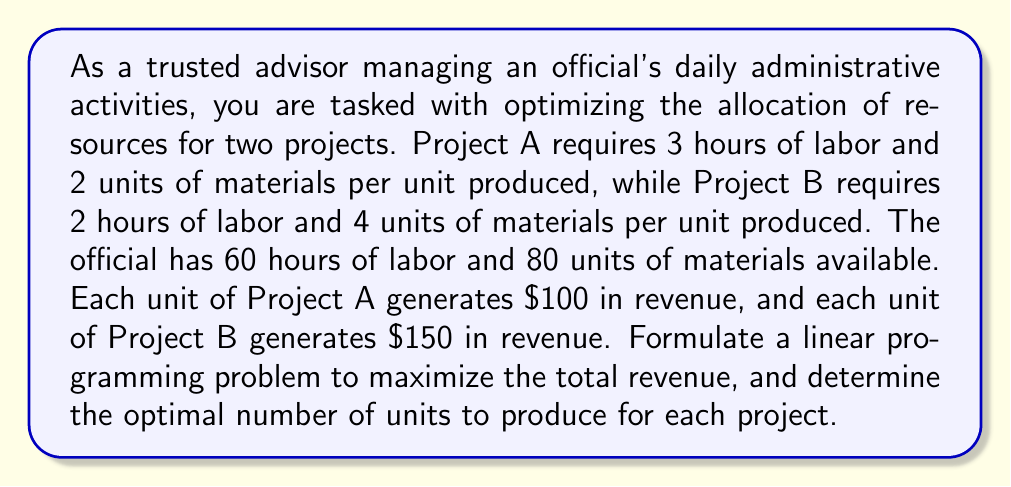Give your solution to this math problem. Let's approach this step-by-step:

1) Define variables:
   Let $x$ be the number of units produced for Project A
   Let $y$ be the number of units produced for Project B

2) Objective function:
   Maximize revenue: $Z = 100x + 150y$

3) Constraints:
   Labor constraint: $3x + 2y \leq 60$
   Material constraint: $2x + 4y \leq 80$
   Non-negativity: $x \geq 0, y \geq 0$

4) The complete linear programming problem:

   Maximize $Z = 100x + 150y$
   Subject to:
   $$\begin{align}
   3x + 2y &\leq 60 \\
   2x + 4y &\leq 80 \\
   x, y &\geq 0
   \end{align}$$

5) To solve this, we can use the graphical method:

   [asy]
   import graph;
   size(200,200);
   
   xaxis("x",0,40);
   yaxis("y",0,40);
   
   draw((0,30)--(20,0),blue);
   label("3x + 2y = 60",(-2,32),blue);
   
   draw((0,20)--(40,0),red);
   label("2x + 4y = 80",(42,-2),red);
   
   fill((0,0)--(0,20)--(20,10)--(20,0)--cycle,gray(0.9));
   
   dot((0,20));
   dot((20,10));
   dot((40,0));
   
   label("(0,20)",(0,20),SW);
   label("(20,10)",(20,10),SE);
   label("(40,0)",(40,0),SE);
   [/asy]

6) The feasible region is the shaded area. The optimal solution will be at one of the corner points.

7) Evaluate $Z$ at each corner point:
   At (0,0): $Z = 0$
   At (0,20): $Z = 150(20) = 3000$
   At (20,10): $Z = 100(20) + 150(10) = 3500$
   At (40,0): $Z = 100(40) = 4000$

8) The maximum value of $Z$ occurs at (20,10).
Answer: The optimal solution is to produce 20 units of Project A and 10 units of Project B, which will generate a maximum revenue of $3500. 